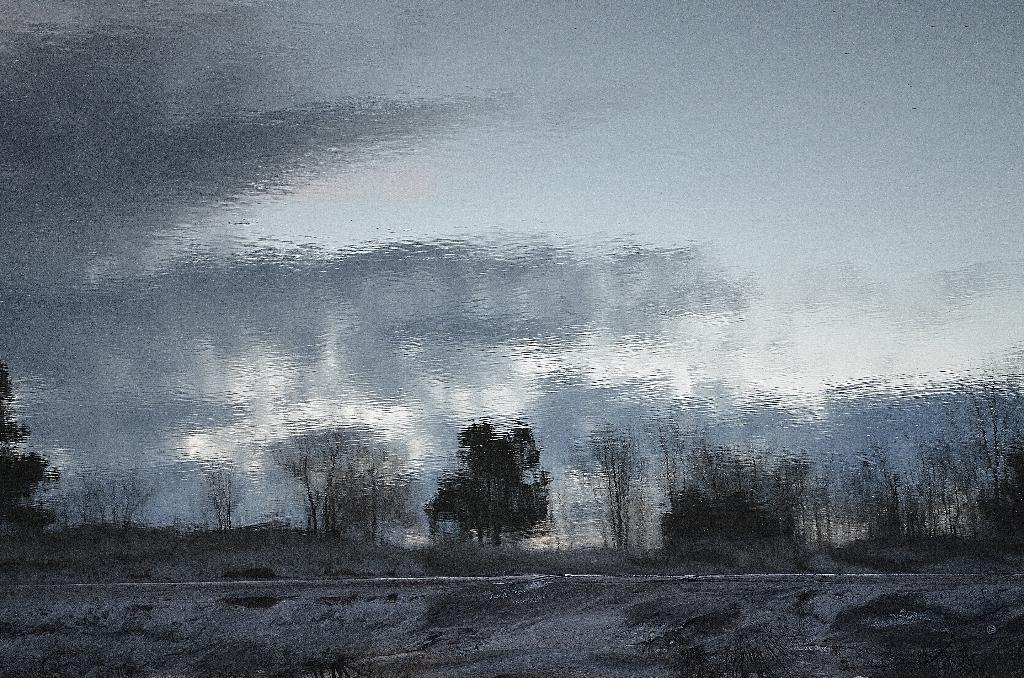What is the main subject of the image? There is a painting in the image. What is depicted in the painting? The painting depicts a cloudy sky. What else can be seen in the image besides the painting? There is a road visible in the image, and there are many trees as well. Where is the toothpaste located in the image? There is no toothpaste present in the image. Can you describe the dog in the image? There is no dog present in the image. 